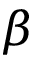<formula> <loc_0><loc_0><loc_500><loc_500>\beta</formula> 